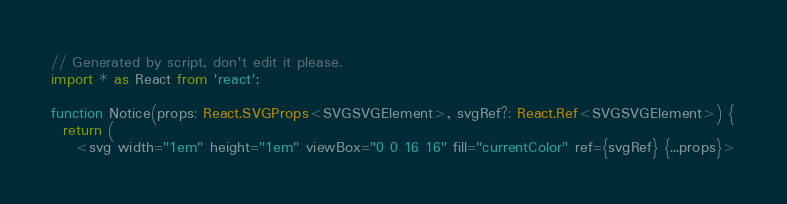<code> <loc_0><loc_0><loc_500><loc_500><_TypeScript_>// Generated by script, don't edit it please.
import * as React from 'react';

function Notice(props: React.SVGProps<SVGSVGElement>, svgRef?: React.Ref<SVGSVGElement>) {
  return (
    <svg width="1em" height="1em" viewBox="0 0 16 16" fill="currentColor" ref={svgRef} {...props}></code> 